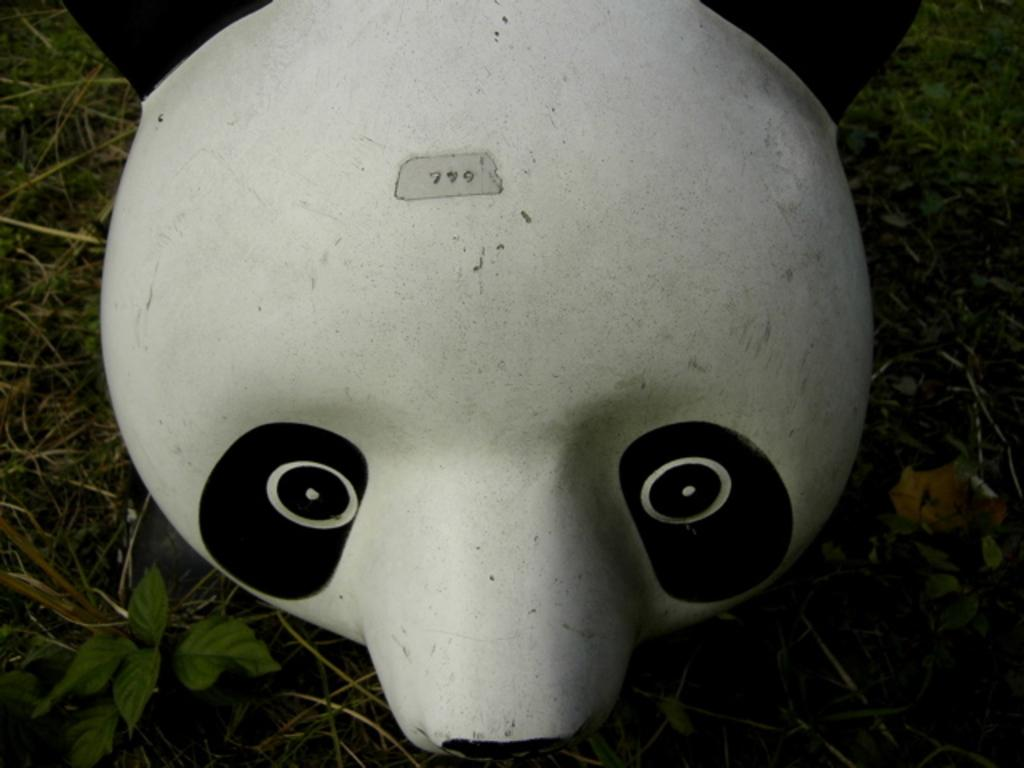What type of toy is present in the image? There is a panda head toy in the image. Where is the panda head toy located? The panda head toy is on the grass. How many faucets can be seen in the image? There are no faucets present in the image. What type of wheel is visible in the image? There is no wheel present in the image. How many clocks are visible in the image? There are no clocks present in the image. 